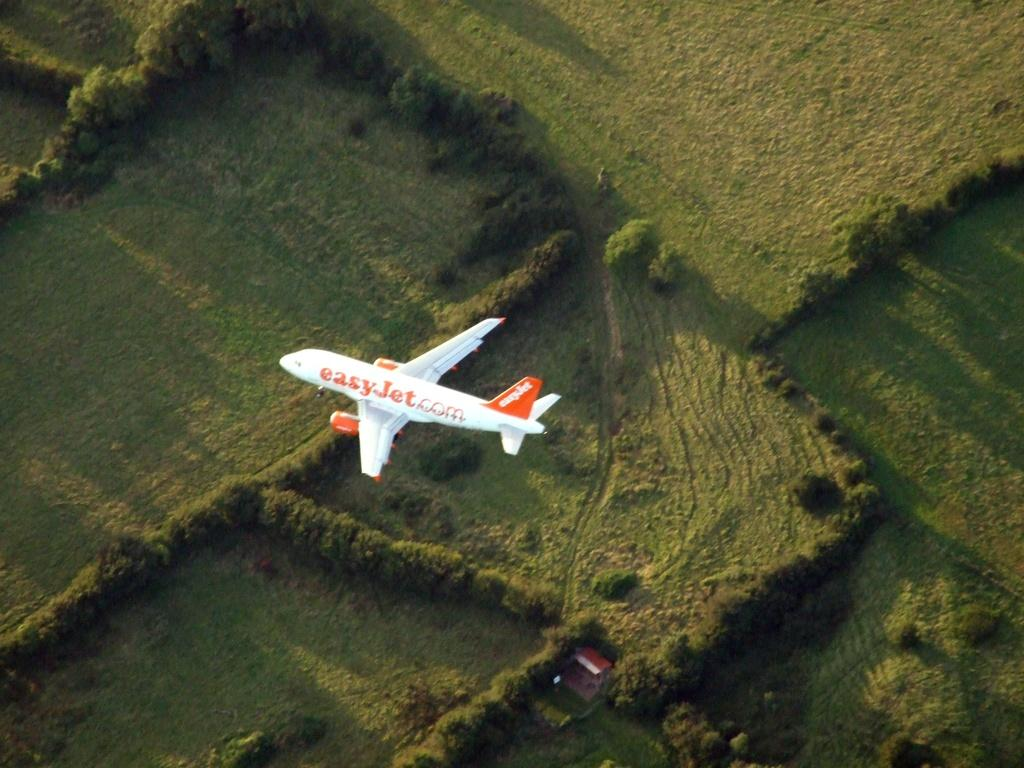<image>
Describe the image concisely. An Easy Jet brand plane flies above a field. 